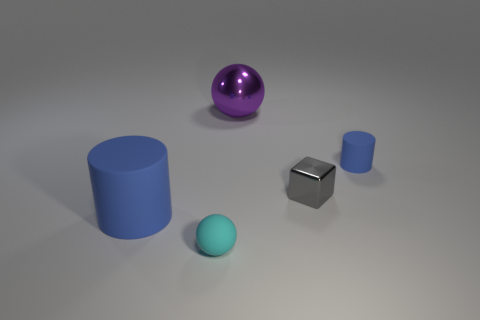Can you describe the objects in terms of their colors and shapes? Certainly! There are four objects in the image, each with a distinct color and shape. The first object is a cylinder with a vibrant blue color. The second is a smaller sphere with a shiny purple hue. Third is a cube with a metallic sheen, reflecting light on its surface. Lastly, there's a small sphere with a matte teal color. 